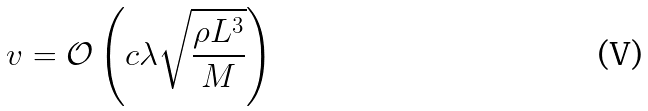<formula> <loc_0><loc_0><loc_500><loc_500>v = \mathcal { O } \left ( c \lambda \sqrt { \frac { \rho L ^ { 3 } } { M } } \right )</formula> 